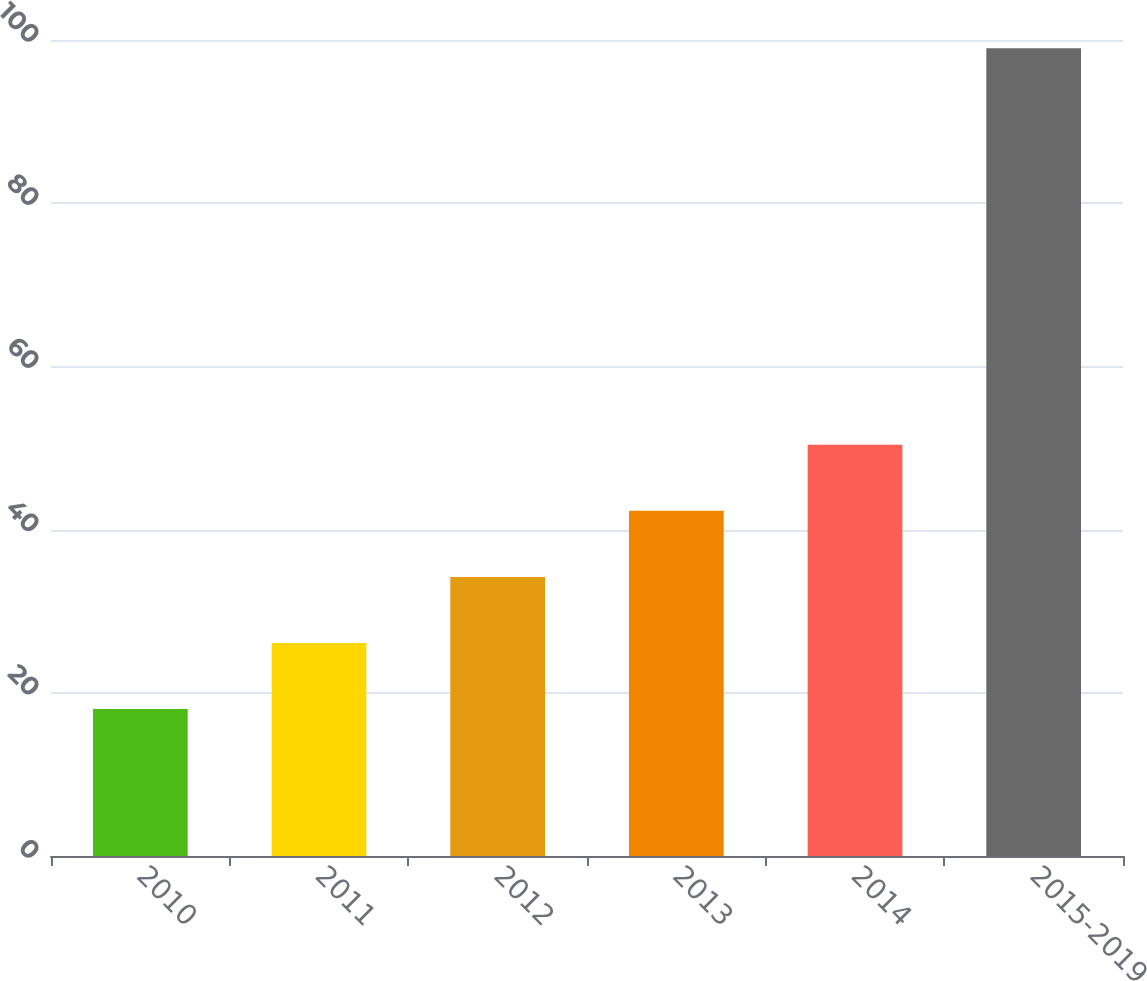Convert chart to OTSL. <chart><loc_0><loc_0><loc_500><loc_500><bar_chart><fcel>2010<fcel>2011<fcel>2012<fcel>2013<fcel>2014<fcel>2015-2019<nl><fcel>18<fcel>26.1<fcel>34.2<fcel>42.3<fcel>50.4<fcel>99<nl></chart> 